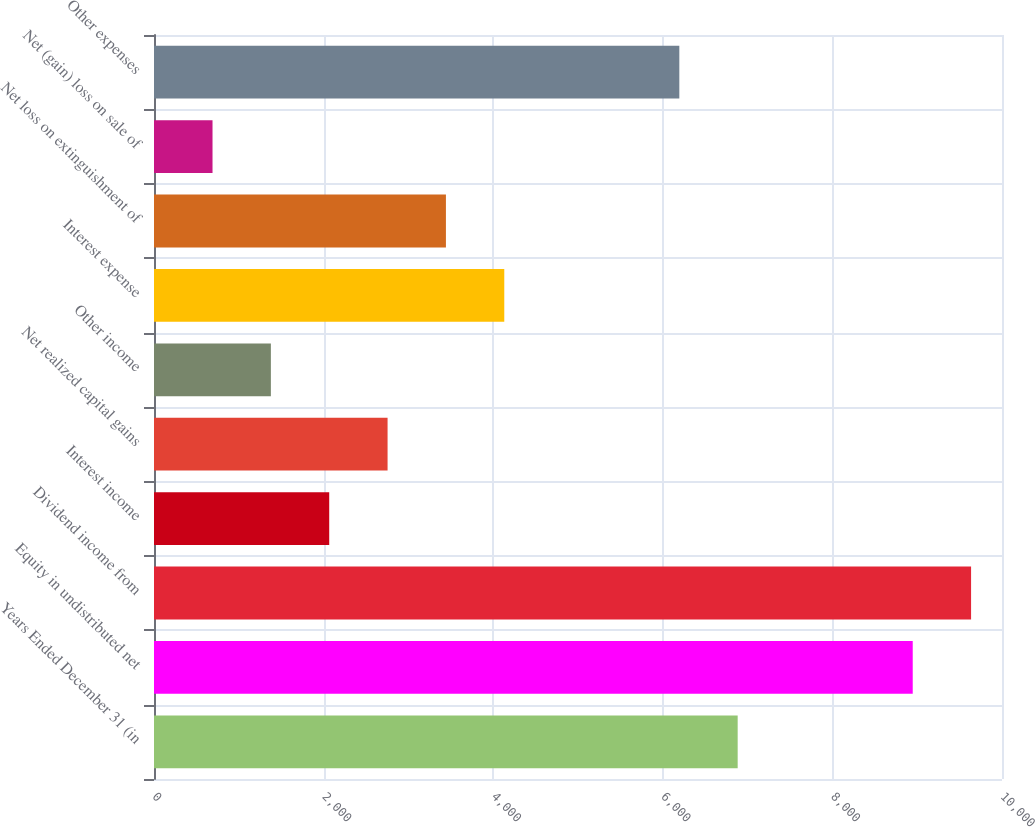<chart> <loc_0><loc_0><loc_500><loc_500><bar_chart><fcel>Years Ended December 31 (in<fcel>Equity in undistributed net<fcel>Dividend income from<fcel>Interest income<fcel>Net realized capital gains<fcel>Other income<fcel>Interest expense<fcel>Net loss on extinguishment of<fcel>Net (gain) loss on sale of<fcel>Other expenses<nl><fcel>6883<fcel>8947.3<fcel>9635.4<fcel>2066.3<fcel>2754.4<fcel>1378.2<fcel>4130.6<fcel>3442.5<fcel>690.1<fcel>6194.9<nl></chart> 